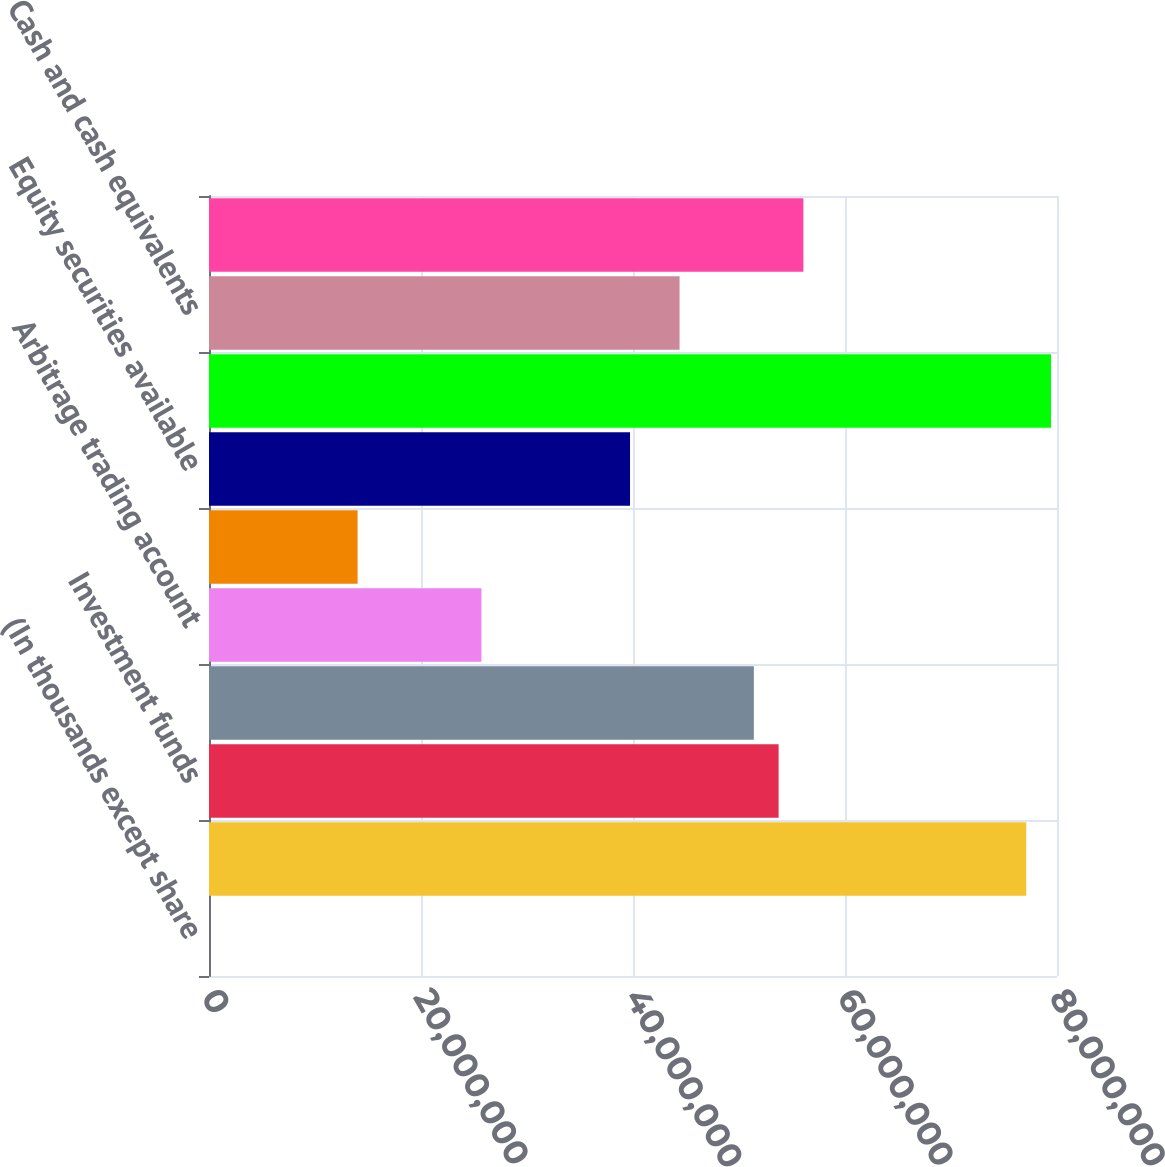Convert chart. <chart><loc_0><loc_0><loc_500><loc_500><bar_chart><fcel>(In thousands except share<fcel>Fixed maturity securities<fcel>Investment funds<fcel>Real estate<fcel>Arbitrage trading account<fcel>Loans receivable<fcel>Equity securities available<fcel>Total investments<fcel>Cash and cash equivalents<fcel>Premiums and fees receivable<nl><fcel>2016<fcel>7.70993e+07<fcel>5.37365e+07<fcel>5.14002e+07<fcel>2.57011e+07<fcel>1.40197e+07<fcel>3.97188e+07<fcel>7.94356e+07<fcel>4.43914e+07<fcel>5.60728e+07<nl></chart> 